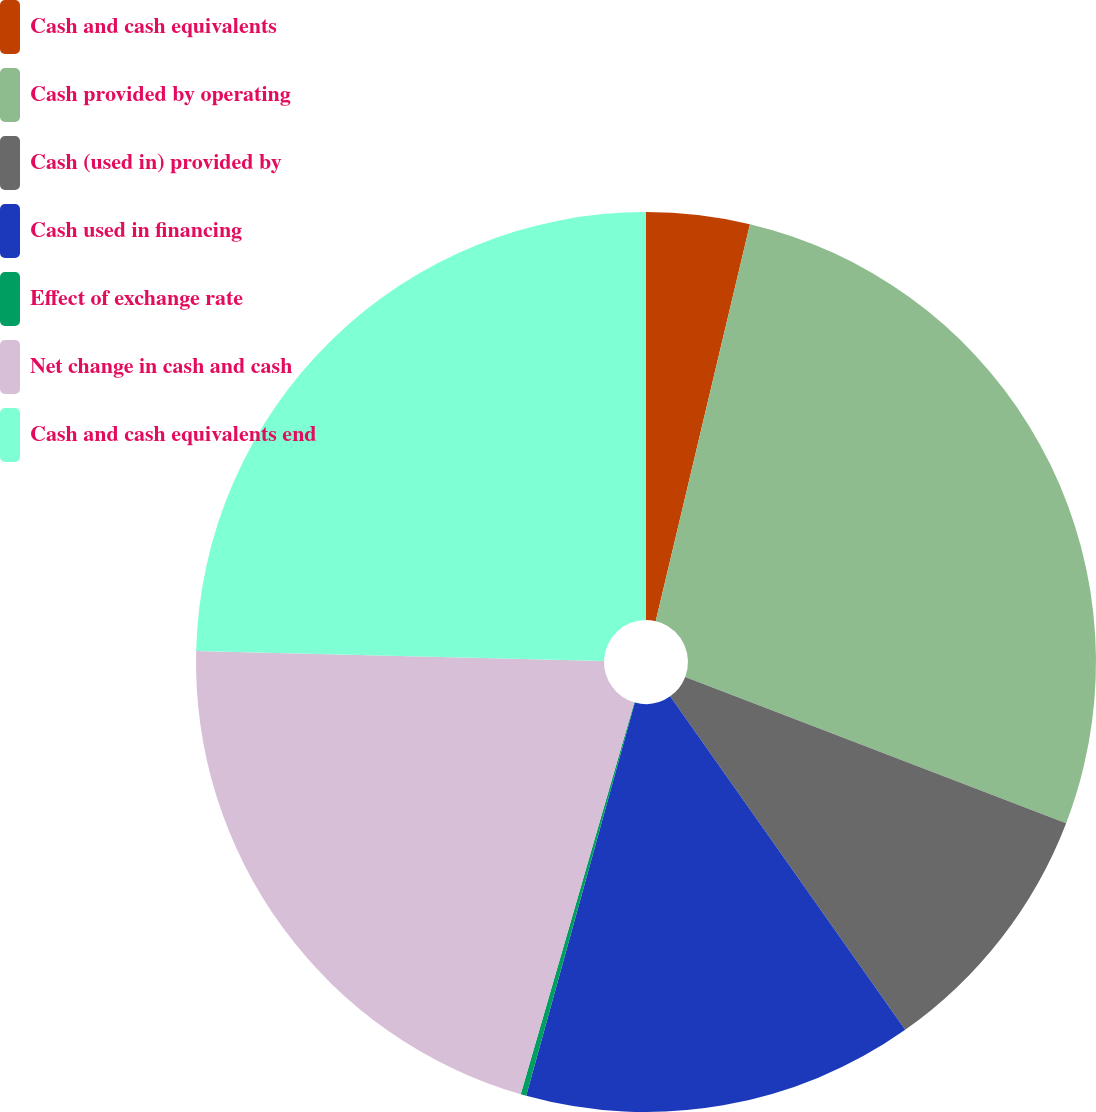<chart> <loc_0><loc_0><loc_500><loc_500><pie_chart><fcel>Cash and cash equivalents<fcel>Cash provided by operating<fcel>Cash (used in) provided by<fcel>Cash used in financing<fcel>Effect of exchange rate<fcel>Net change in cash and cash<fcel>Cash and cash equivalents end<nl><fcel>3.71%<fcel>27.12%<fcel>9.4%<fcel>14.06%<fcel>0.2%<fcel>20.9%<fcel>24.61%<nl></chart> 